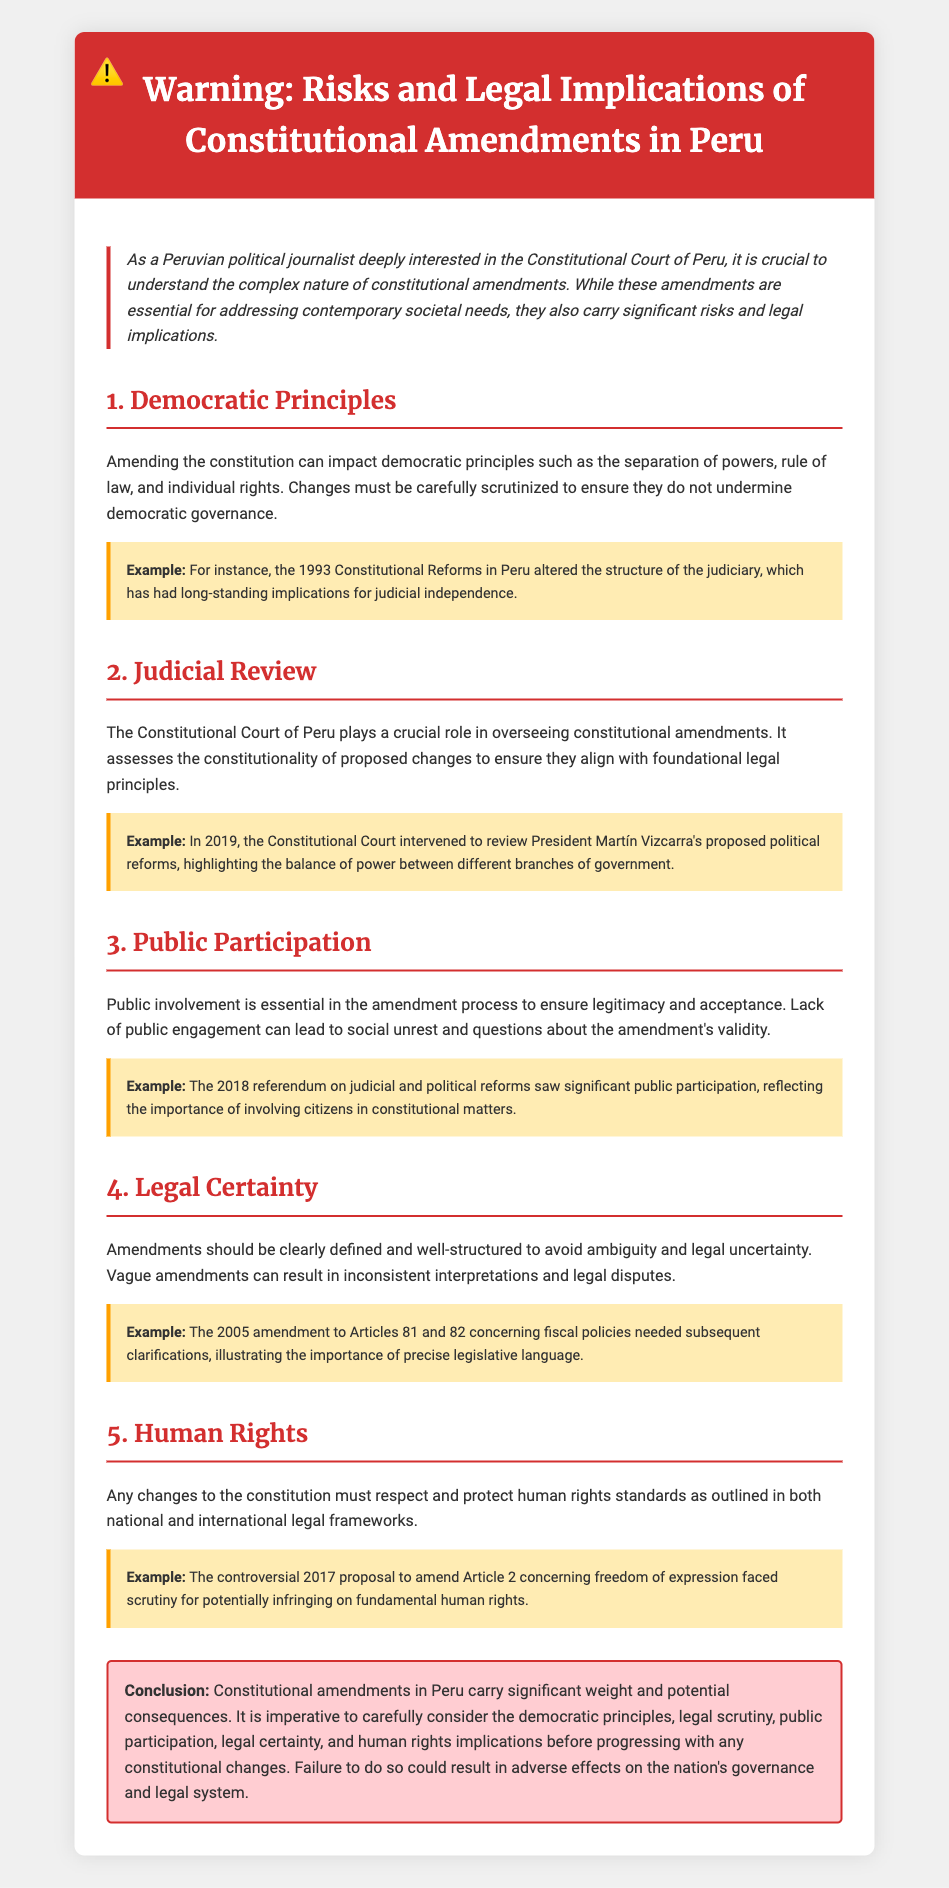What is the title of the document? The title is indicated in the header of the document, summarizing its main focus.
Answer: Warning: Risks and Legal Implications of Constitutional Amendments in Peru What year did the Constitutional Court intervene regarding political reforms? The document mentions a specific event that occurred in the year 2019.
Answer: 2019 What does the introduction emphasize about constitutional amendments? The introduction discusses the importance of understanding the nature of constitutional amendments.
Answer: Complex nature What was an example of public participation mentioned in the document? The document provides an example of a specific event that reflects significant public engagement.
Answer: 2018 referendum What is a primary concern of amending the constitution according to the document? The document lists various concerns that arise with constitutional amendments, focusing on democratic principles.
Answer: Democratic principles Which article was proposed to be amended in 2017? The document identifies a specific article related to freedom of expression that faced scrutiny.
Answer: Article 2 What is highlighted as essential in the amendment process? The document stresses the importance of a particular aspect in the process of amending the constitution.
Answer: Public involvement According to the document, what must amendments respect? The document outlines what standards should be upheld in constitutional amendments related to rights.
Answer: Human rights standards What is a potential consequence of vague amendments? The document describes a specific problem that can arise from poorly defined amendments.
Answer: Legal disputes 